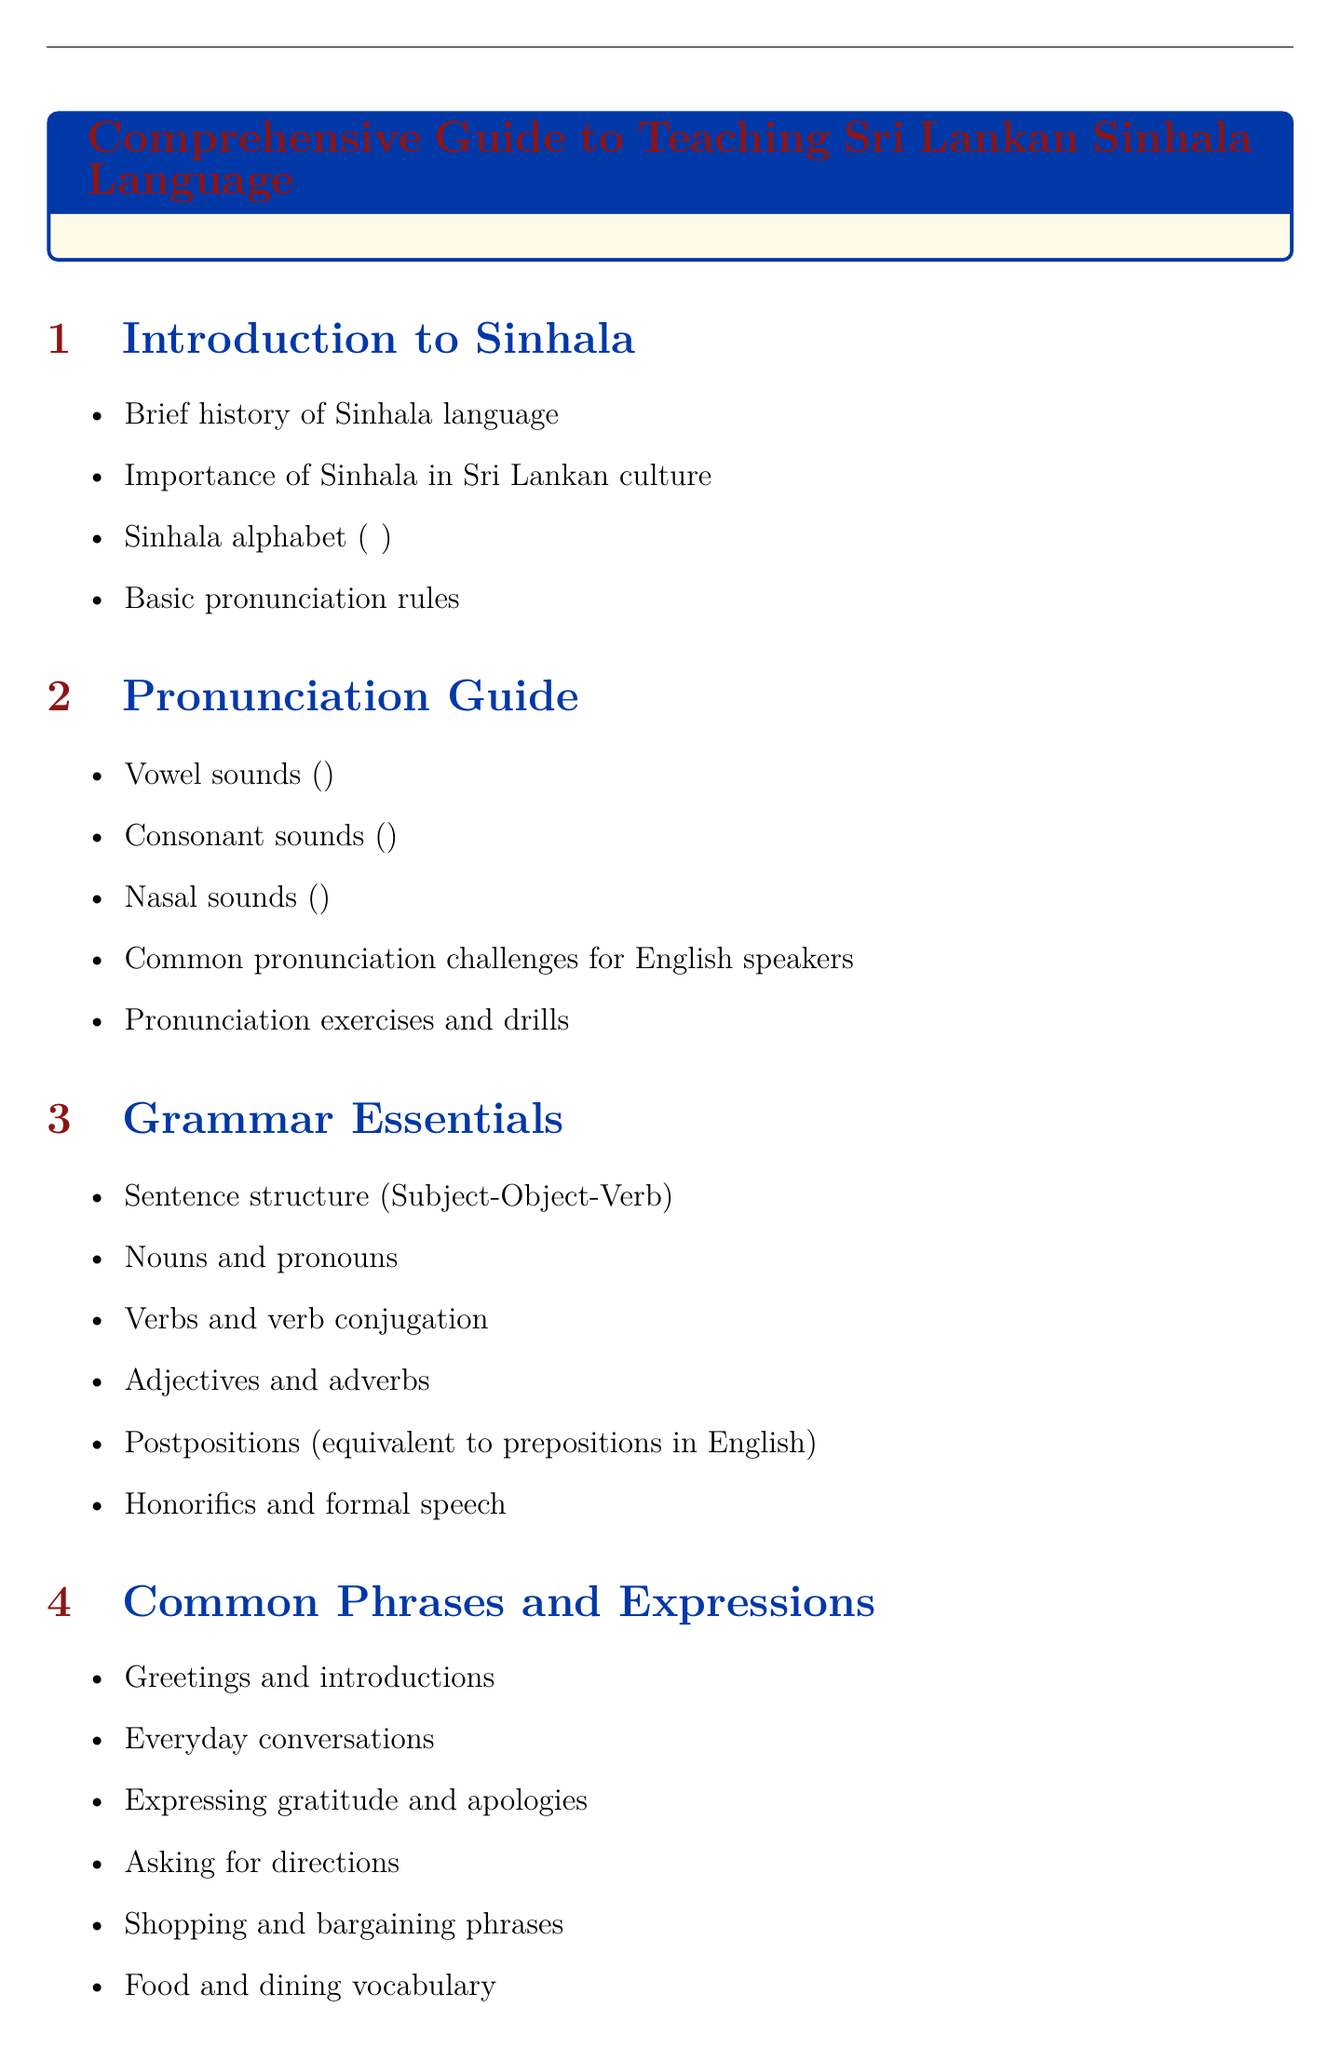What is the title of the document? The title of the document is found at the top and summarizes what the guide covers.
Answer: Comprehensive Guide to Teaching Sri Lankan Sinhala Language What are the basic pronunciation rules? This information is listed in the section about Sinhala pronunciation, indicating key aspects of sound.
Answer: Basic pronunciation rules How many sections are in the document? The total number of sections is enumerated, representing different educational areas of the guide.
Answer: 9 What is the Sinhala term for "thank you"? The specific term is outlined in the "Sample Phrases" section, illustrating a common expression of gratitude.
Answer: ස්තුතියි What teaching methodology suggests immersion techniques? This refers to one of the strategies described for effective language teaching in the context of Sinhala.
Answer: Immersion techniques Name one cultural activity mentioned in the document. The document enumerates various cultural activities to enhance understanding and connection with Sri Lankan culture.
Answer: Preparing and sharing traditional Sri Lankan dishes What is the structure of sentences in Sinhala? The document specifies how sentences are generally formed in the Sinhala language, providing essential grammar information.
Answer: Subject-Object-Verb What online resource is recommended for learning Sinhala? This resource is mentioned in the 'Resources' section as a means of enhancing language skills through online courses.
Answer: University of Kelaniya's distance learning program What is the purpose of the "Assessment and Progress Tracking" section? This section provides ways to evaluate learning outcomes effectively.
Answer: Evaluate learning outcomes 